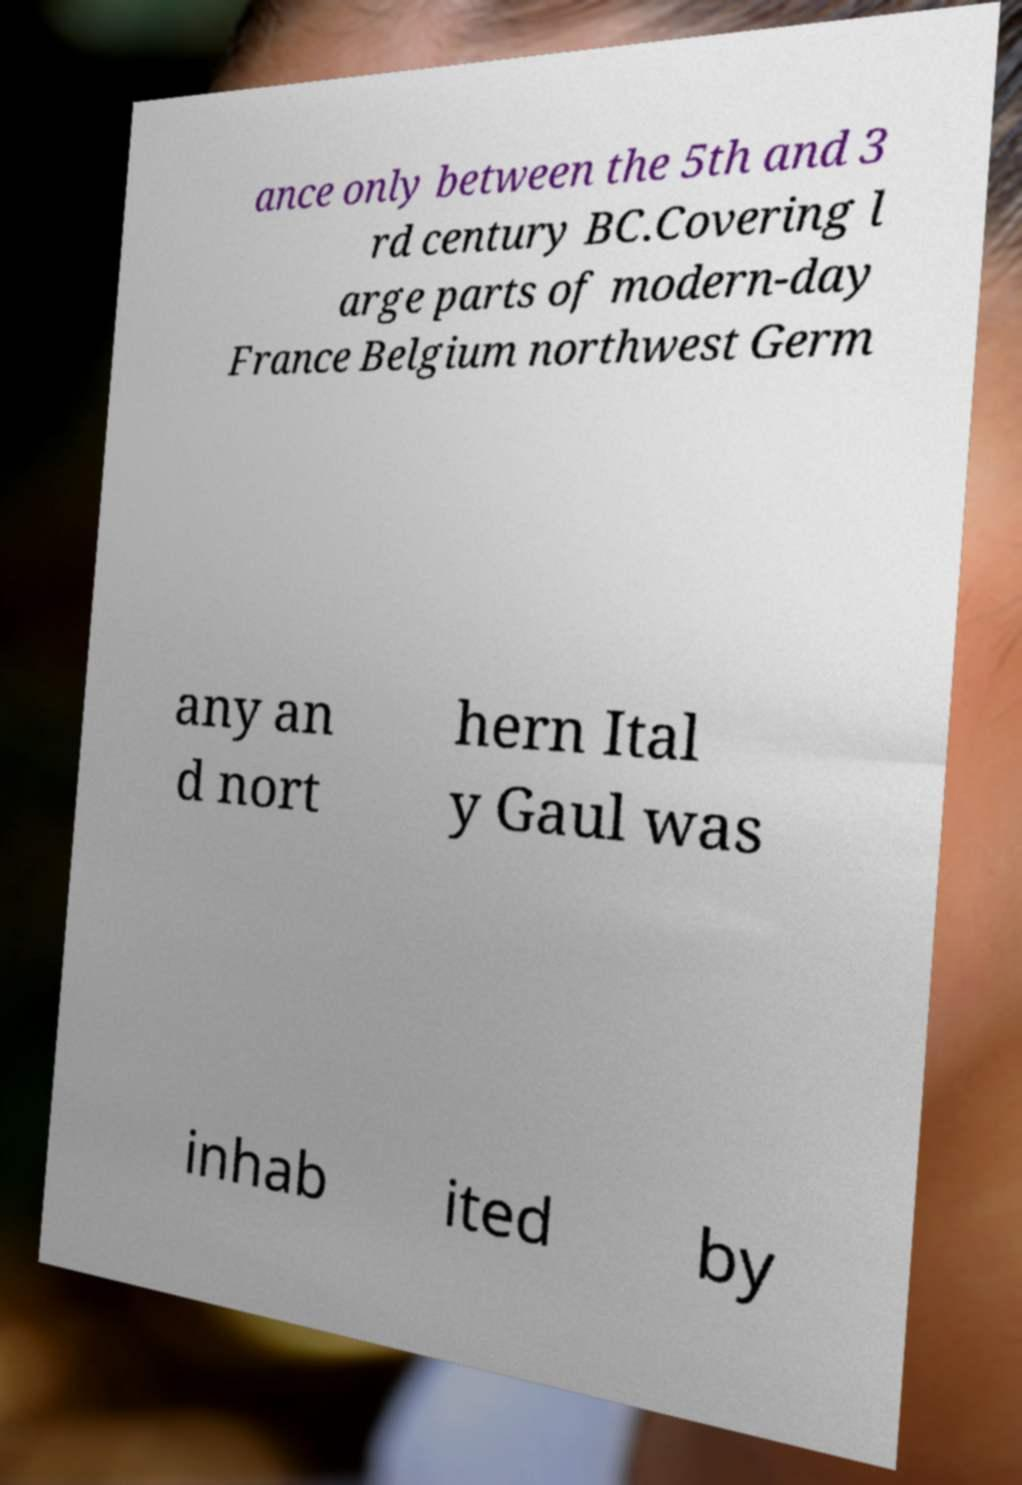I need the written content from this picture converted into text. Can you do that? ance only between the 5th and 3 rd century BC.Covering l arge parts of modern-day France Belgium northwest Germ any an d nort hern Ital y Gaul was inhab ited by 